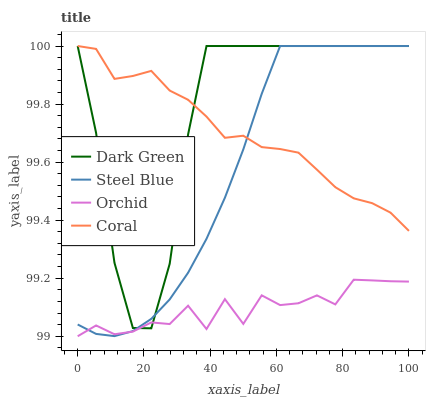Does Orchid have the minimum area under the curve?
Answer yes or no. Yes. Does Dark Green have the maximum area under the curve?
Answer yes or no. Yes. Does Steel Blue have the minimum area under the curve?
Answer yes or no. No. Does Steel Blue have the maximum area under the curve?
Answer yes or no. No. Is Steel Blue the smoothest?
Answer yes or no. Yes. Is Dark Green the roughest?
Answer yes or no. Yes. Is Orchid the smoothest?
Answer yes or no. No. Is Orchid the roughest?
Answer yes or no. No. Does Orchid have the lowest value?
Answer yes or no. Yes. Does Steel Blue have the lowest value?
Answer yes or no. No. Does Dark Green have the highest value?
Answer yes or no. Yes. Does Orchid have the highest value?
Answer yes or no. No. Is Orchid less than Coral?
Answer yes or no. Yes. Is Coral greater than Orchid?
Answer yes or no. Yes. Does Steel Blue intersect Orchid?
Answer yes or no. Yes. Is Steel Blue less than Orchid?
Answer yes or no. No. Is Steel Blue greater than Orchid?
Answer yes or no. No. Does Orchid intersect Coral?
Answer yes or no. No. 